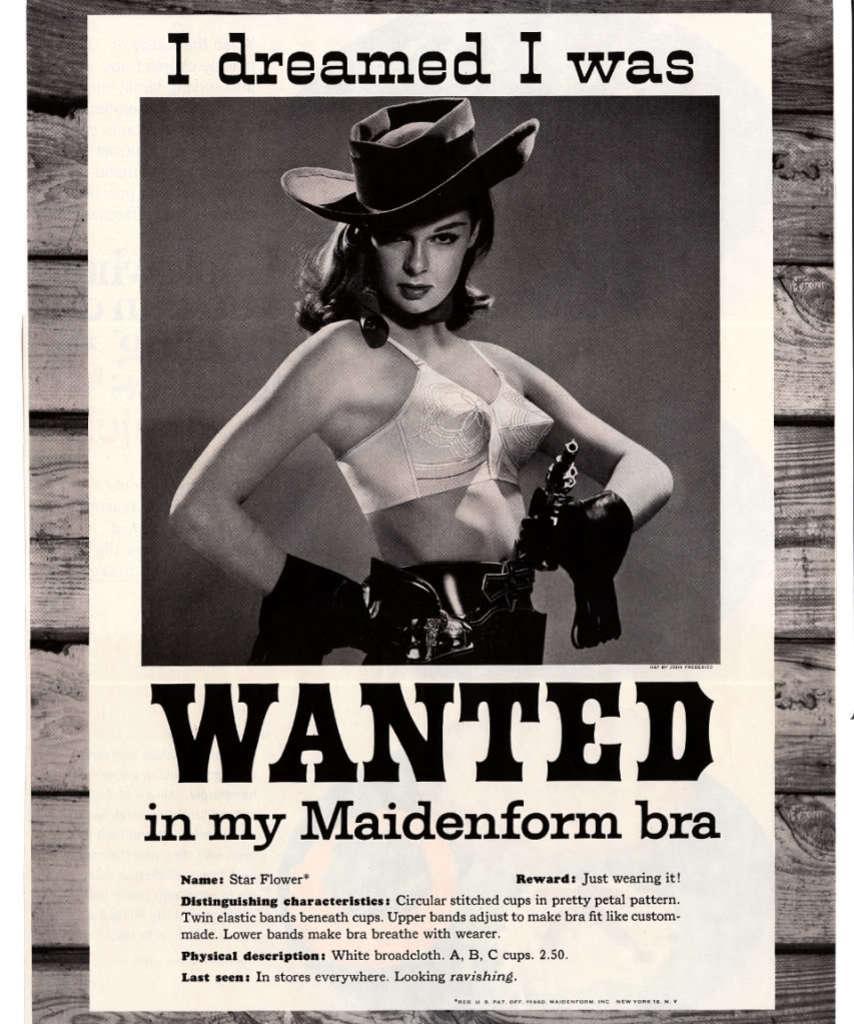Can you describe this image briefly? In this image I can see the person is wearing the hat and something is written on the poster. The poster is attached to the wooden surface. The image is in black and white. 